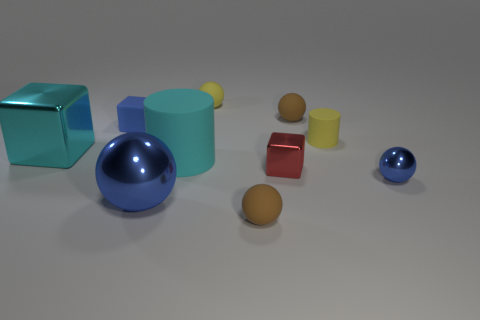Subtract all yellow cylinders. How many cylinders are left? 1 Subtract all tiny matte cubes. How many cubes are left? 2 Subtract 0 yellow cubes. How many objects are left? 10 Subtract all cubes. How many objects are left? 7 Subtract 2 spheres. How many spheres are left? 3 Subtract all gray blocks. Subtract all gray balls. How many blocks are left? 3 Subtract all cyan cylinders. How many yellow blocks are left? 0 Subtract all small blue things. Subtract all large brown shiny balls. How many objects are left? 8 Add 2 tiny shiny spheres. How many tiny shiny spheres are left? 3 Add 6 yellow matte cylinders. How many yellow matte cylinders exist? 7 